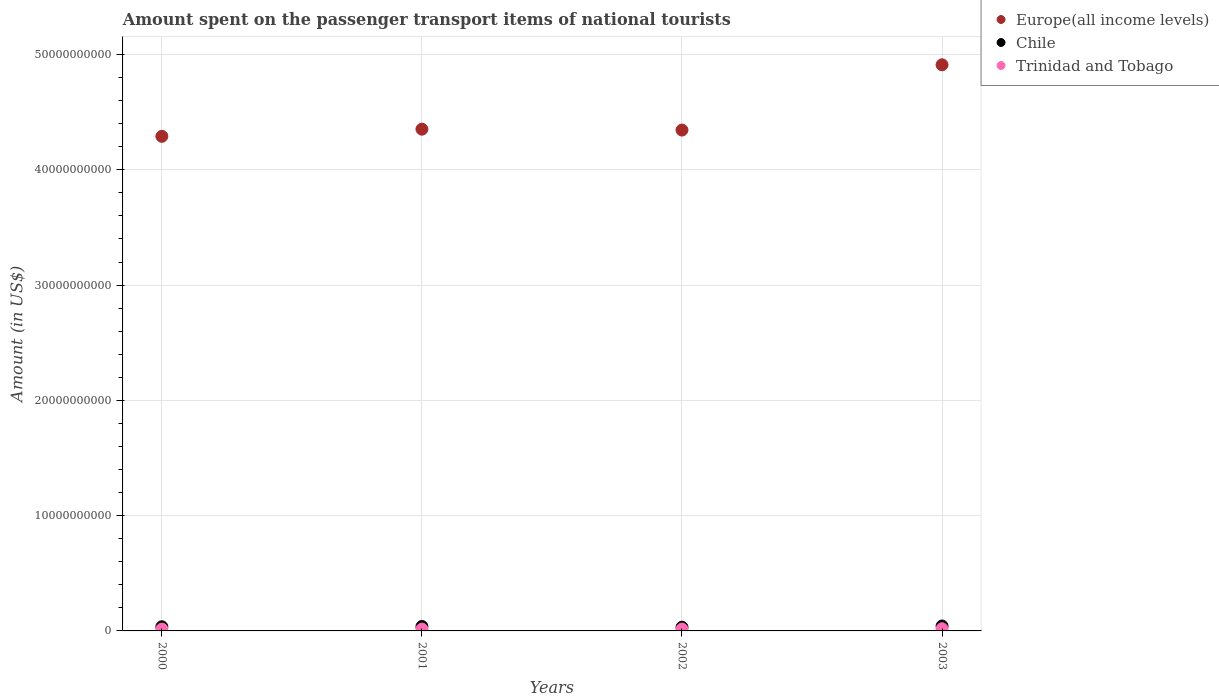How many different coloured dotlines are there?
Offer a terse response. 3. What is the amount spent on the passenger transport items of national tourists in Trinidad and Tobago in 2000?
Ensure brevity in your answer.  1.58e+08. Across all years, what is the maximum amount spent on the passenger transport items of national tourists in Trinidad and Tobago?
Make the answer very short. 1.88e+08. Across all years, what is the minimum amount spent on the passenger transport items of national tourists in Europe(all income levels)?
Keep it short and to the point. 4.29e+1. What is the total amount spent on the passenger transport items of national tourists in Europe(all income levels) in the graph?
Provide a succinct answer. 1.79e+11. What is the difference between the amount spent on the passenger transport items of national tourists in Europe(all income levels) in 2000 and that in 2001?
Keep it short and to the point. -6.21e+08. What is the difference between the amount spent on the passenger transport items of national tourists in Trinidad and Tobago in 2003 and the amount spent on the passenger transport items of national tourists in Europe(all income levels) in 2000?
Your answer should be very brief. -4.27e+1. What is the average amount spent on the passenger transport items of national tourists in Chile per year?
Offer a terse response. 3.74e+08. In the year 2002, what is the difference between the amount spent on the passenger transport items of national tourists in Europe(all income levels) and amount spent on the passenger transport items of national tourists in Trinidad and Tobago?
Give a very brief answer. 4.33e+1. What is the ratio of the amount spent on the passenger transport items of national tourists in Trinidad and Tobago in 2000 to that in 2001?
Your response must be concise. 0.99. Is the difference between the amount spent on the passenger transport items of national tourists in Europe(all income levels) in 2001 and 2003 greater than the difference between the amount spent on the passenger transport items of national tourists in Trinidad and Tobago in 2001 and 2003?
Give a very brief answer. No. What is the difference between the highest and the second highest amount spent on the passenger transport items of national tourists in Europe(all income levels)?
Make the answer very short. 5.58e+09. What is the difference between the highest and the lowest amount spent on the passenger transport items of national tourists in Trinidad and Tobago?
Give a very brief answer. 3.00e+07. In how many years, is the amount spent on the passenger transport items of national tourists in Chile greater than the average amount spent on the passenger transport items of national tourists in Chile taken over all years?
Offer a terse response. 2. Is it the case that in every year, the sum of the amount spent on the passenger transport items of national tourists in Chile and amount spent on the passenger transport items of national tourists in Europe(all income levels)  is greater than the amount spent on the passenger transport items of national tourists in Trinidad and Tobago?
Offer a very short reply. Yes. Does the amount spent on the passenger transport items of national tourists in Chile monotonically increase over the years?
Give a very brief answer. No. Is the amount spent on the passenger transport items of national tourists in Chile strictly greater than the amount spent on the passenger transport items of national tourists in Trinidad and Tobago over the years?
Your response must be concise. Yes. Are the values on the major ticks of Y-axis written in scientific E-notation?
Provide a short and direct response. No. Does the graph contain grids?
Your response must be concise. Yes. How many legend labels are there?
Offer a very short reply. 3. How are the legend labels stacked?
Your response must be concise. Vertical. What is the title of the graph?
Provide a succinct answer. Amount spent on the passenger transport items of national tourists. What is the label or title of the X-axis?
Your answer should be very brief. Years. What is the Amount (in US$) in Europe(all income levels) in 2000?
Provide a succinct answer. 4.29e+1. What is the Amount (in US$) in Chile in 2000?
Your answer should be very brief. 3.60e+08. What is the Amount (in US$) in Trinidad and Tobago in 2000?
Provide a succinct answer. 1.58e+08. What is the Amount (in US$) of Europe(all income levels) in 2001?
Your response must be concise. 4.35e+1. What is the Amount (in US$) of Chile in 2001?
Make the answer very short. 3.85e+08. What is the Amount (in US$) in Trinidad and Tobago in 2001?
Offer a terse response. 1.60e+08. What is the Amount (in US$) of Europe(all income levels) in 2002?
Your response must be concise. 4.34e+1. What is the Amount (in US$) in Chile in 2002?
Give a very brief answer. 3.23e+08. What is the Amount (in US$) of Trinidad and Tobago in 2002?
Keep it short and to the point. 1.60e+08. What is the Amount (in US$) in Europe(all income levels) in 2003?
Keep it short and to the point. 4.91e+1. What is the Amount (in US$) of Chile in 2003?
Ensure brevity in your answer.  4.26e+08. What is the Amount (in US$) in Trinidad and Tobago in 2003?
Your answer should be very brief. 1.88e+08. Across all years, what is the maximum Amount (in US$) of Europe(all income levels)?
Make the answer very short. 4.91e+1. Across all years, what is the maximum Amount (in US$) in Chile?
Keep it short and to the point. 4.26e+08. Across all years, what is the maximum Amount (in US$) in Trinidad and Tobago?
Offer a terse response. 1.88e+08. Across all years, what is the minimum Amount (in US$) in Europe(all income levels)?
Ensure brevity in your answer.  4.29e+1. Across all years, what is the minimum Amount (in US$) of Chile?
Provide a succinct answer. 3.23e+08. Across all years, what is the minimum Amount (in US$) in Trinidad and Tobago?
Keep it short and to the point. 1.58e+08. What is the total Amount (in US$) in Europe(all income levels) in the graph?
Provide a short and direct response. 1.79e+11. What is the total Amount (in US$) of Chile in the graph?
Keep it short and to the point. 1.49e+09. What is the total Amount (in US$) of Trinidad and Tobago in the graph?
Provide a succinct answer. 6.66e+08. What is the difference between the Amount (in US$) of Europe(all income levels) in 2000 and that in 2001?
Your response must be concise. -6.21e+08. What is the difference between the Amount (in US$) of Chile in 2000 and that in 2001?
Ensure brevity in your answer.  -2.50e+07. What is the difference between the Amount (in US$) of Trinidad and Tobago in 2000 and that in 2001?
Your response must be concise. -2.00e+06. What is the difference between the Amount (in US$) of Europe(all income levels) in 2000 and that in 2002?
Your answer should be compact. -5.42e+08. What is the difference between the Amount (in US$) of Chile in 2000 and that in 2002?
Keep it short and to the point. 3.70e+07. What is the difference between the Amount (in US$) in Europe(all income levels) in 2000 and that in 2003?
Ensure brevity in your answer.  -6.21e+09. What is the difference between the Amount (in US$) of Chile in 2000 and that in 2003?
Your answer should be very brief. -6.60e+07. What is the difference between the Amount (in US$) of Trinidad and Tobago in 2000 and that in 2003?
Your answer should be very brief. -3.00e+07. What is the difference between the Amount (in US$) in Europe(all income levels) in 2001 and that in 2002?
Ensure brevity in your answer.  7.86e+07. What is the difference between the Amount (in US$) of Chile in 2001 and that in 2002?
Offer a very short reply. 6.20e+07. What is the difference between the Amount (in US$) in Europe(all income levels) in 2001 and that in 2003?
Offer a very short reply. -5.58e+09. What is the difference between the Amount (in US$) in Chile in 2001 and that in 2003?
Your response must be concise. -4.10e+07. What is the difference between the Amount (in US$) in Trinidad and Tobago in 2001 and that in 2003?
Make the answer very short. -2.80e+07. What is the difference between the Amount (in US$) in Europe(all income levels) in 2002 and that in 2003?
Provide a short and direct response. -5.66e+09. What is the difference between the Amount (in US$) of Chile in 2002 and that in 2003?
Keep it short and to the point. -1.03e+08. What is the difference between the Amount (in US$) of Trinidad and Tobago in 2002 and that in 2003?
Your answer should be very brief. -2.80e+07. What is the difference between the Amount (in US$) of Europe(all income levels) in 2000 and the Amount (in US$) of Chile in 2001?
Ensure brevity in your answer.  4.25e+1. What is the difference between the Amount (in US$) of Europe(all income levels) in 2000 and the Amount (in US$) of Trinidad and Tobago in 2001?
Your answer should be compact. 4.27e+1. What is the difference between the Amount (in US$) of Chile in 2000 and the Amount (in US$) of Trinidad and Tobago in 2001?
Provide a succinct answer. 2.00e+08. What is the difference between the Amount (in US$) of Europe(all income levels) in 2000 and the Amount (in US$) of Chile in 2002?
Provide a succinct answer. 4.26e+1. What is the difference between the Amount (in US$) of Europe(all income levels) in 2000 and the Amount (in US$) of Trinidad and Tobago in 2002?
Keep it short and to the point. 4.27e+1. What is the difference between the Amount (in US$) of Chile in 2000 and the Amount (in US$) of Trinidad and Tobago in 2002?
Offer a very short reply. 2.00e+08. What is the difference between the Amount (in US$) in Europe(all income levels) in 2000 and the Amount (in US$) in Chile in 2003?
Offer a very short reply. 4.25e+1. What is the difference between the Amount (in US$) of Europe(all income levels) in 2000 and the Amount (in US$) of Trinidad and Tobago in 2003?
Your answer should be very brief. 4.27e+1. What is the difference between the Amount (in US$) of Chile in 2000 and the Amount (in US$) of Trinidad and Tobago in 2003?
Keep it short and to the point. 1.72e+08. What is the difference between the Amount (in US$) of Europe(all income levels) in 2001 and the Amount (in US$) of Chile in 2002?
Your answer should be very brief. 4.32e+1. What is the difference between the Amount (in US$) of Europe(all income levels) in 2001 and the Amount (in US$) of Trinidad and Tobago in 2002?
Offer a very short reply. 4.34e+1. What is the difference between the Amount (in US$) in Chile in 2001 and the Amount (in US$) in Trinidad and Tobago in 2002?
Make the answer very short. 2.25e+08. What is the difference between the Amount (in US$) in Europe(all income levels) in 2001 and the Amount (in US$) in Chile in 2003?
Offer a terse response. 4.31e+1. What is the difference between the Amount (in US$) of Europe(all income levels) in 2001 and the Amount (in US$) of Trinidad and Tobago in 2003?
Keep it short and to the point. 4.33e+1. What is the difference between the Amount (in US$) in Chile in 2001 and the Amount (in US$) in Trinidad and Tobago in 2003?
Provide a succinct answer. 1.97e+08. What is the difference between the Amount (in US$) of Europe(all income levels) in 2002 and the Amount (in US$) of Chile in 2003?
Offer a very short reply. 4.30e+1. What is the difference between the Amount (in US$) of Europe(all income levels) in 2002 and the Amount (in US$) of Trinidad and Tobago in 2003?
Offer a terse response. 4.33e+1. What is the difference between the Amount (in US$) in Chile in 2002 and the Amount (in US$) in Trinidad and Tobago in 2003?
Provide a short and direct response. 1.35e+08. What is the average Amount (in US$) of Europe(all income levels) per year?
Provide a short and direct response. 4.47e+1. What is the average Amount (in US$) of Chile per year?
Give a very brief answer. 3.74e+08. What is the average Amount (in US$) of Trinidad and Tobago per year?
Keep it short and to the point. 1.66e+08. In the year 2000, what is the difference between the Amount (in US$) in Europe(all income levels) and Amount (in US$) in Chile?
Your response must be concise. 4.25e+1. In the year 2000, what is the difference between the Amount (in US$) in Europe(all income levels) and Amount (in US$) in Trinidad and Tobago?
Give a very brief answer. 4.27e+1. In the year 2000, what is the difference between the Amount (in US$) in Chile and Amount (in US$) in Trinidad and Tobago?
Offer a very short reply. 2.02e+08. In the year 2001, what is the difference between the Amount (in US$) of Europe(all income levels) and Amount (in US$) of Chile?
Keep it short and to the point. 4.31e+1. In the year 2001, what is the difference between the Amount (in US$) of Europe(all income levels) and Amount (in US$) of Trinidad and Tobago?
Keep it short and to the point. 4.34e+1. In the year 2001, what is the difference between the Amount (in US$) in Chile and Amount (in US$) in Trinidad and Tobago?
Your response must be concise. 2.25e+08. In the year 2002, what is the difference between the Amount (in US$) in Europe(all income levels) and Amount (in US$) in Chile?
Offer a very short reply. 4.31e+1. In the year 2002, what is the difference between the Amount (in US$) in Europe(all income levels) and Amount (in US$) in Trinidad and Tobago?
Offer a very short reply. 4.33e+1. In the year 2002, what is the difference between the Amount (in US$) in Chile and Amount (in US$) in Trinidad and Tobago?
Your response must be concise. 1.63e+08. In the year 2003, what is the difference between the Amount (in US$) in Europe(all income levels) and Amount (in US$) in Chile?
Ensure brevity in your answer.  4.87e+1. In the year 2003, what is the difference between the Amount (in US$) in Europe(all income levels) and Amount (in US$) in Trinidad and Tobago?
Offer a terse response. 4.89e+1. In the year 2003, what is the difference between the Amount (in US$) of Chile and Amount (in US$) of Trinidad and Tobago?
Provide a succinct answer. 2.38e+08. What is the ratio of the Amount (in US$) of Europe(all income levels) in 2000 to that in 2001?
Provide a short and direct response. 0.99. What is the ratio of the Amount (in US$) in Chile in 2000 to that in 2001?
Offer a terse response. 0.94. What is the ratio of the Amount (in US$) of Trinidad and Tobago in 2000 to that in 2001?
Your answer should be compact. 0.99. What is the ratio of the Amount (in US$) in Europe(all income levels) in 2000 to that in 2002?
Offer a very short reply. 0.99. What is the ratio of the Amount (in US$) in Chile in 2000 to that in 2002?
Your response must be concise. 1.11. What is the ratio of the Amount (in US$) in Trinidad and Tobago in 2000 to that in 2002?
Your answer should be very brief. 0.99. What is the ratio of the Amount (in US$) in Europe(all income levels) in 2000 to that in 2003?
Your answer should be compact. 0.87. What is the ratio of the Amount (in US$) of Chile in 2000 to that in 2003?
Offer a very short reply. 0.85. What is the ratio of the Amount (in US$) in Trinidad and Tobago in 2000 to that in 2003?
Give a very brief answer. 0.84. What is the ratio of the Amount (in US$) in Europe(all income levels) in 2001 to that in 2002?
Give a very brief answer. 1. What is the ratio of the Amount (in US$) of Chile in 2001 to that in 2002?
Offer a very short reply. 1.19. What is the ratio of the Amount (in US$) of Europe(all income levels) in 2001 to that in 2003?
Provide a succinct answer. 0.89. What is the ratio of the Amount (in US$) in Chile in 2001 to that in 2003?
Offer a terse response. 0.9. What is the ratio of the Amount (in US$) of Trinidad and Tobago in 2001 to that in 2003?
Your answer should be very brief. 0.85. What is the ratio of the Amount (in US$) in Europe(all income levels) in 2002 to that in 2003?
Provide a succinct answer. 0.88. What is the ratio of the Amount (in US$) in Chile in 2002 to that in 2003?
Your response must be concise. 0.76. What is the ratio of the Amount (in US$) of Trinidad and Tobago in 2002 to that in 2003?
Your response must be concise. 0.85. What is the difference between the highest and the second highest Amount (in US$) of Europe(all income levels)?
Make the answer very short. 5.58e+09. What is the difference between the highest and the second highest Amount (in US$) in Chile?
Your answer should be compact. 4.10e+07. What is the difference between the highest and the second highest Amount (in US$) in Trinidad and Tobago?
Offer a terse response. 2.80e+07. What is the difference between the highest and the lowest Amount (in US$) in Europe(all income levels)?
Provide a short and direct response. 6.21e+09. What is the difference between the highest and the lowest Amount (in US$) of Chile?
Offer a terse response. 1.03e+08. What is the difference between the highest and the lowest Amount (in US$) of Trinidad and Tobago?
Your response must be concise. 3.00e+07. 